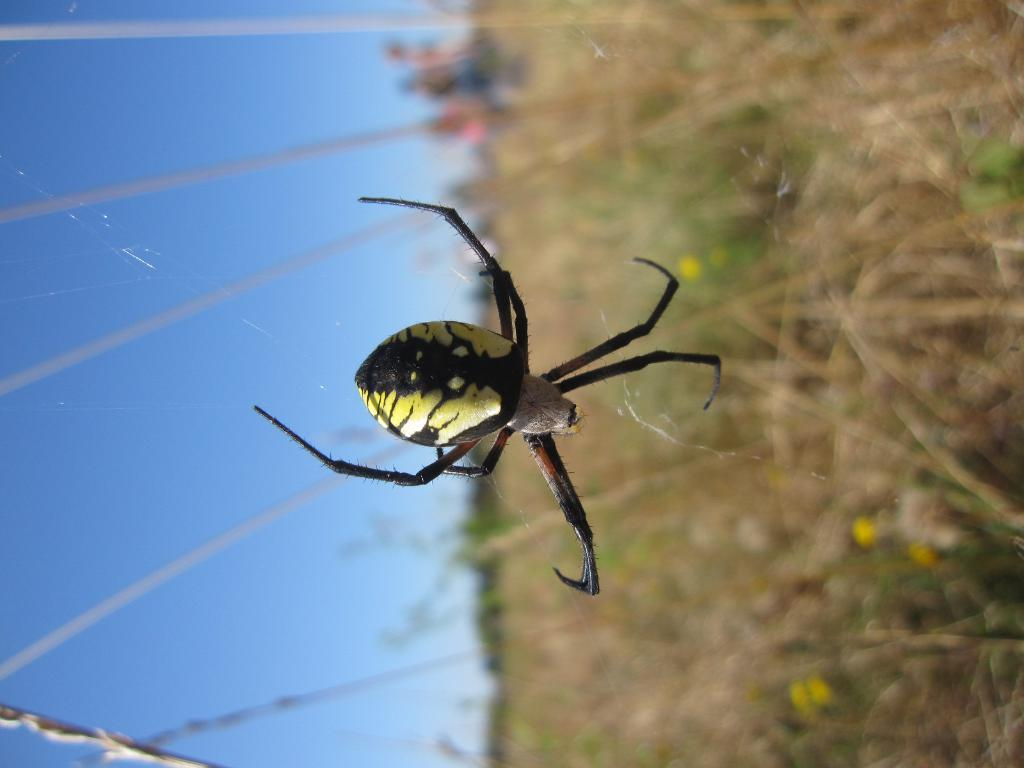What can be seen in the background of the image? The sky is visible in the image. What type of living organism is present in the image? There is an insect in the image. How would you describe the quality of the right side of the image? The right side of the image is blurry. What type of vegetation is present in the image? There are plants in the image. What type of tomatoes can be seen growing on the wall in the image? There is no wall or tomatoes present in the image. How does the insect plan to attack the plants in the image? The image does not show any indication of an attack, and insects do not plan attacks. 